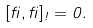<formula> <loc_0><loc_0><loc_500><loc_500>[ \beta , \beta ] _ { \omega } = 0 .</formula> 